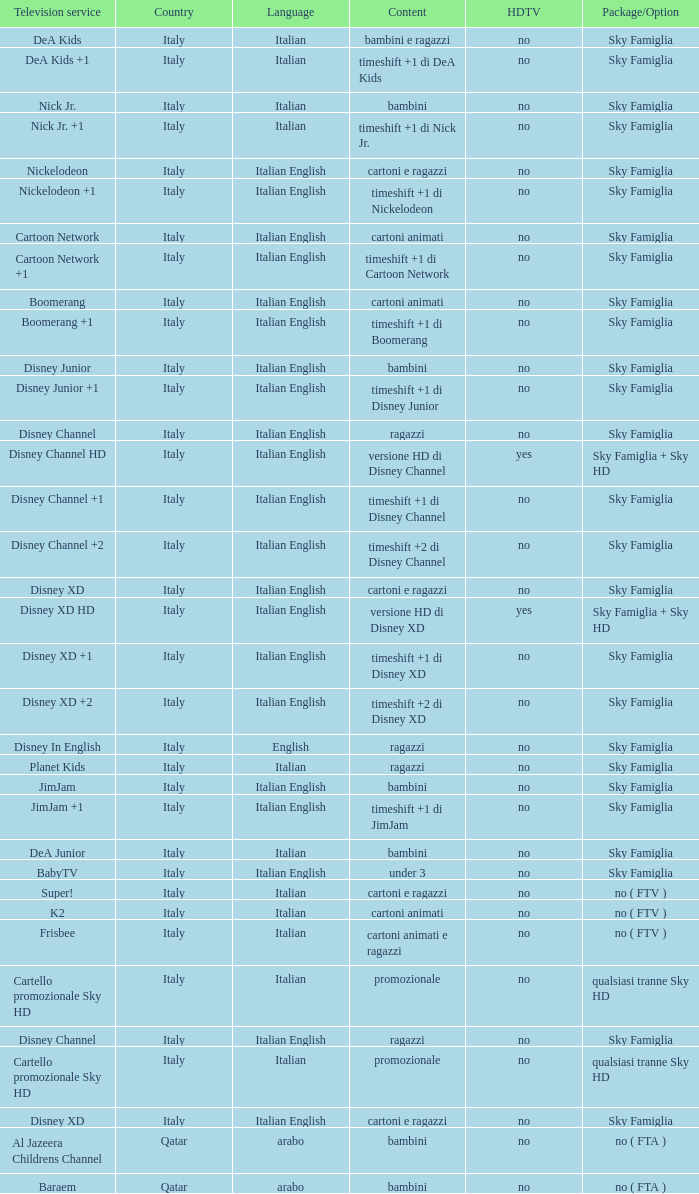What type of content is featured on the television service of nickelodeon +1? Timeshift +1 di nickelodeon. Can you parse all the data within this table? {'header': ['Television service', 'Country', 'Language', 'Content', 'HDTV', 'Package/Option'], 'rows': [['DeA Kids', 'Italy', 'Italian', 'bambini e ragazzi', 'no', 'Sky Famiglia'], ['DeA Kids +1', 'Italy', 'Italian', 'timeshift +1 di DeA Kids', 'no', 'Sky Famiglia'], ['Nick Jr.', 'Italy', 'Italian', 'bambini', 'no', 'Sky Famiglia'], ['Nick Jr. +1', 'Italy', 'Italian', 'timeshift +1 di Nick Jr.', 'no', 'Sky Famiglia'], ['Nickelodeon', 'Italy', 'Italian English', 'cartoni e ragazzi', 'no', 'Sky Famiglia'], ['Nickelodeon +1', 'Italy', 'Italian English', 'timeshift +1 di Nickelodeon', 'no', 'Sky Famiglia'], ['Cartoon Network', 'Italy', 'Italian English', 'cartoni animati', 'no', 'Sky Famiglia'], ['Cartoon Network +1', 'Italy', 'Italian English', 'timeshift +1 di Cartoon Network', 'no', 'Sky Famiglia'], ['Boomerang', 'Italy', 'Italian English', 'cartoni animati', 'no', 'Sky Famiglia'], ['Boomerang +1', 'Italy', 'Italian English', 'timeshift +1 di Boomerang', 'no', 'Sky Famiglia'], ['Disney Junior', 'Italy', 'Italian English', 'bambini', 'no', 'Sky Famiglia'], ['Disney Junior +1', 'Italy', 'Italian English', 'timeshift +1 di Disney Junior', 'no', 'Sky Famiglia'], ['Disney Channel', 'Italy', 'Italian English', 'ragazzi', 'no', 'Sky Famiglia'], ['Disney Channel HD', 'Italy', 'Italian English', 'versione HD di Disney Channel', 'yes', 'Sky Famiglia + Sky HD'], ['Disney Channel +1', 'Italy', 'Italian English', 'timeshift +1 di Disney Channel', 'no', 'Sky Famiglia'], ['Disney Channel +2', 'Italy', 'Italian English', 'timeshift +2 di Disney Channel', 'no', 'Sky Famiglia'], ['Disney XD', 'Italy', 'Italian English', 'cartoni e ragazzi', 'no', 'Sky Famiglia'], ['Disney XD HD', 'Italy', 'Italian English', 'versione HD di Disney XD', 'yes', 'Sky Famiglia + Sky HD'], ['Disney XD +1', 'Italy', 'Italian English', 'timeshift +1 di Disney XD', 'no', 'Sky Famiglia'], ['Disney XD +2', 'Italy', 'Italian English', 'timeshift +2 di Disney XD', 'no', 'Sky Famiglia'], ['Disney In English', 'Italy', 'English', 'ragazzi', 'no', 'Sky Famiglia'], ['Planet Kids', 'Italy', 'Italian', 'ragazzi', 'no', 'Sky Famiglia'], ['JimJam', 'Italy', 'Italian English', 'bambini', 'no', 'Sky Famiglia'], ['JimJam +1', 'Italy', 'Italian English', 'timeshift +1 di JimJam', 'no', 'Sky Famiglia'], ['DeA Junior', 'Italy', 'Italian', 'bambini', 'no', 'Sky Famiglia'], ['BabyTV', 'Italy', 'Italian English', 'under 3', 'no', 'Sky Famiglia'], ['Super!', 'Italy', 'Italian', 'cartoni e ragazzi', 'no', 'no ( FTV )'], ['K2', 'Italy', 'Italian', 'cartoni animati', 'no', 'no ( FTV )'], ['Frisbee', 'Italy', 'Italian', 'cartoni animati e ragazzi', 'no', 'no ( FTV )'], ['Cartello promozionale Sky HD', 'Italy', 'Italian', 'promozionale', 'no', 'qualsiasi tranne Sky HD'], ['Disney Channel', 'Italy', 'Italian English', 'ragazzi', 'no', 'Sky Famiglia'], ['Cartello promozionale Sky HD', 'Italy', 'Italian', 'promozionale', 'no', 'qualsiasi tranne Sky HD'], ['Disney XD', 'Italy', 'Italian English', 'cartoni e ragazzi', 'no', 'Sky Famiglia'], ['Al Jazeera Childrens Channel', 'Qatar', 'arabo', 'bambini', 'no', 'no ( FTA )'], ['Baraem', 'Qatar', 'arabo', 'bambini', 'no', 'no ( FTA )']]} 